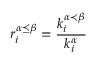<formula> <loc_0><loc_0><loc_500><loc_500>r _ { i } ^ { \alpha \preceq \beta } = \frac { k _ { i } ^ { \alpha \prec \beta } } { k _ { i } ^ { \alpha } }</formula> 